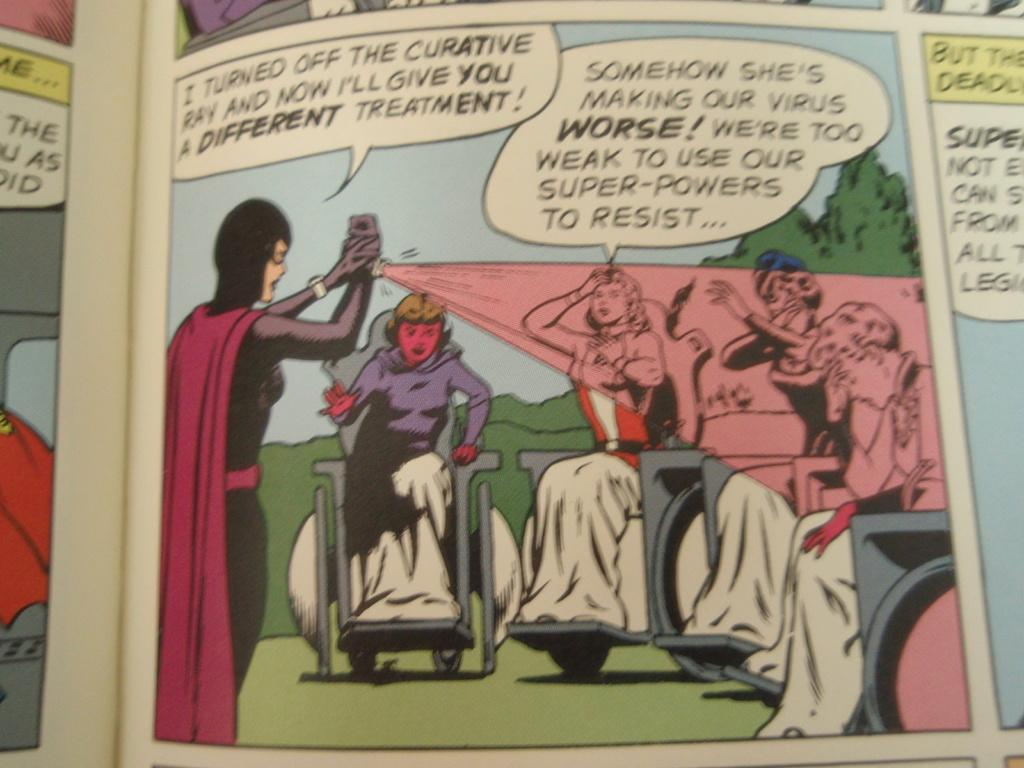<image>
Describe the image concisely. People in wheelchairs are sick with a virus. 